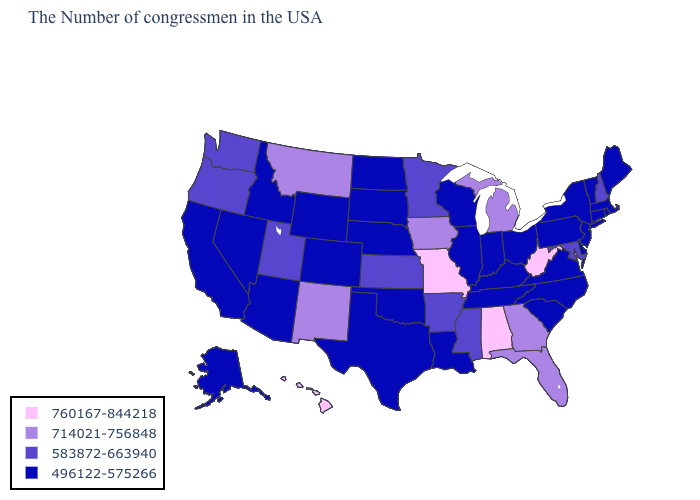Name the states that have a value in the range 714021-756848?
Concise answer only. Florida, Georgia, Michigan, Iowa, New Mexico, Montana. What is the value of New Mexico?
Quick response, please. 714021-756848. What is the value of Connecticut?
Write a very short answer. 496122-575266. Which states hav the highest value in the South?
Write a very short answer. West Virginia, Alabama. Name the states that have a value in the range 583872-663940?
Quick response, please. New Hampshire, Maryland, Mississippi, Arkansas, Minnesota, Kansas, Utah, Washington, Oregon. What is the lowest value in the West?
Be succinct. 496122-575266. Name the states that have a value in the range 760167-844218?
Be succinct. West Virginia, Alabama, Missouri, Hawaii. Does New Mexico have the lowest value in the USA?
Write a very short answer. No. What is the value of Tennessee?
Answer briefly. 496122-575266. Which states have the highest value in the USA?
Be succinct. West Virginia, Alabama, Missouri, Hawaii. Which states have the highest value in the USA?
Concise answer only. West Virginia, Alabama, Missouri, Hawaii. Does Montana have the lowest value in the USA?
Quick response, please. No. Name the states that have a value in the range 760167-844218?
Give a very brief answer. West Virginia, Alabama, Missouri, Hawaii. Name the states that have a value in the range 760167-844218?
Be succinct. West Virginia, Alabama, Missouri, Hawaii. 